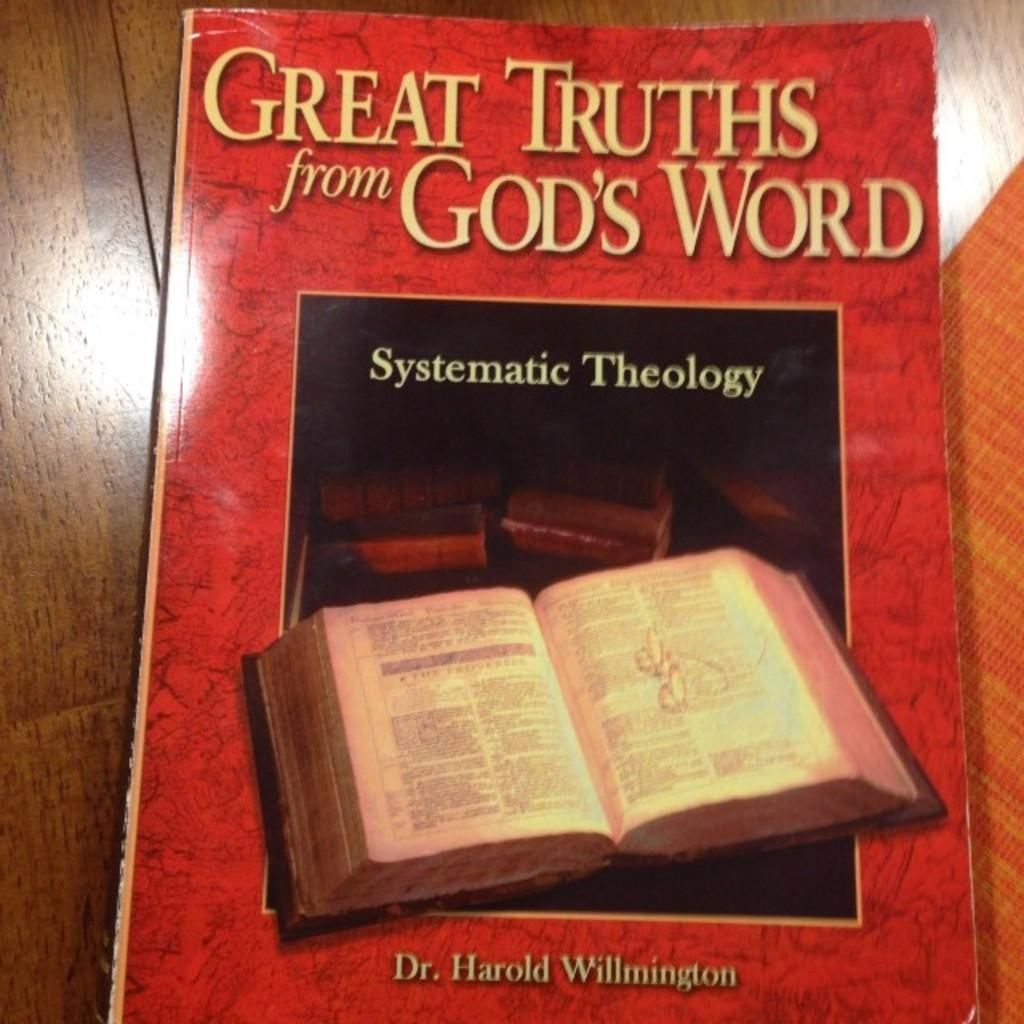<image>
Present a compact description of the photo's key features. A book titled Great Truths from God's Word 